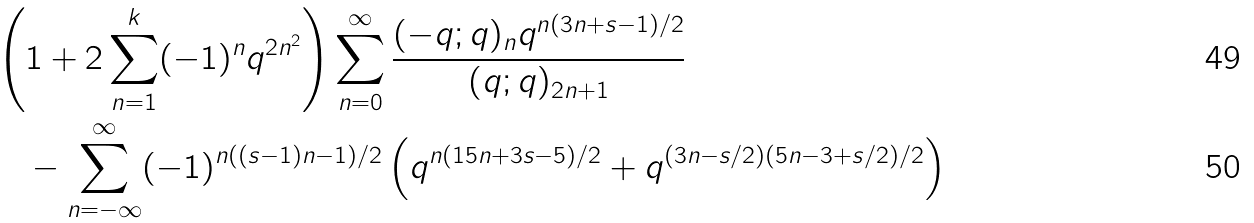Convert formula to latex. <formula><loc_0><loc_0><loc_500><loc_500>& \left ( 1 + 2 \sum _ { n = 1 } ^ { k } ( - 1 ) ^ { n } q ^ { 2 n ^ { 2 } } \right ) \sum _ { n = 0 } ^ { \infty } \frac { ( - q ; q ) _ { n } q ^ { n ( 3 n + s - 1 ) / 2 } } { ( q ; q ) _ { 2 n + 1 } } \\ & \quad - \sum _ { n = - \infty } ^ { \infty } ( - 1 ) ^ { n ( ( s - 1 ) n - 1 ) / 2 } \left ( q ^ { n ( 1 5 n + 3 s - 5 ) / 2 } + q ^ { ( 3 n - s / 2 ) ( 5 n - 3 + s / 2 ) / 2 } \right )</formula> 